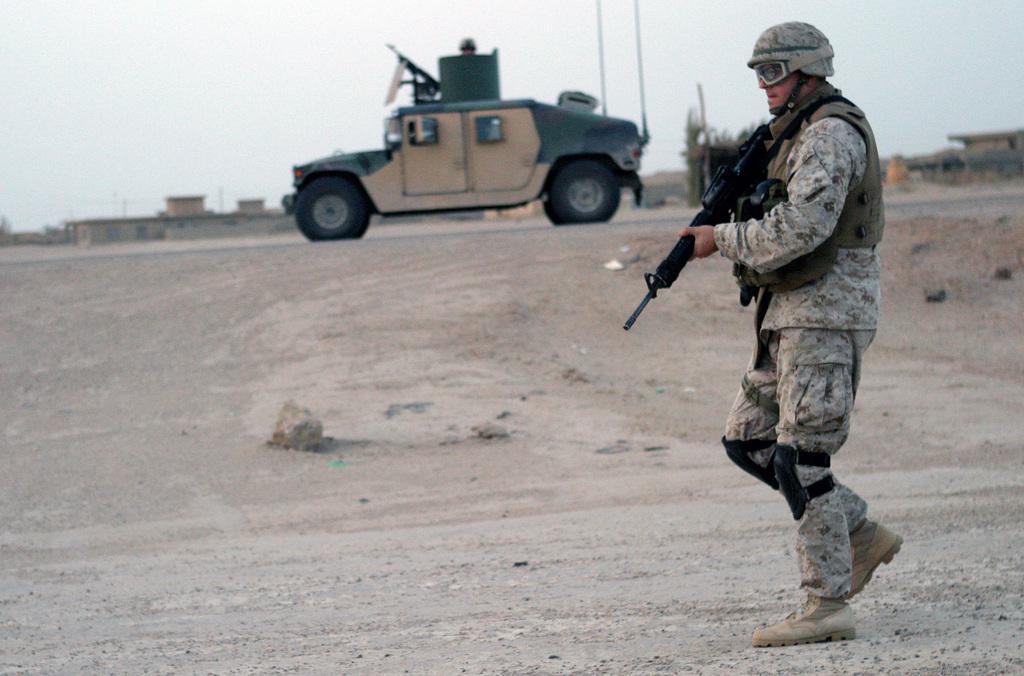Describe this image in one or two sentences. In this image we can see a soldier walking on the road and he is carrying a weapon. He is wearing a safety jacket. Here we can see the vehicle on the road. In the background, we can see the houses. 